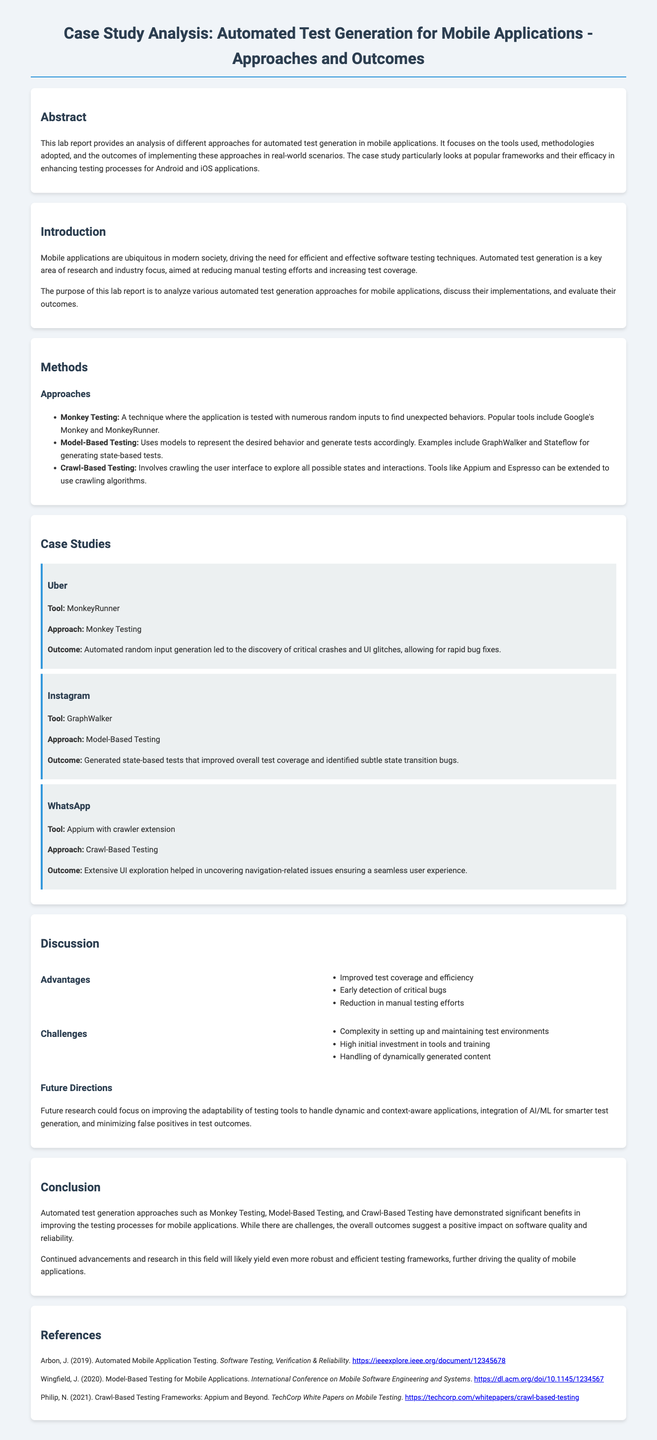What is the purpose of this lab report? The purpose is to analyze various automated test generation approaches for mobile applications, discuss their implementations, and evaluate their outcomes.
Answer: To analyze various automated test generation approaches What testing approach does Uber use? The document states that Uber used Monkey Testing as their approach.
Answer: Monkey Testing What tool is associated with Instagram's testing approach? Instagram's case study mentions GraphWalker as the tool used for testing.
Answer: GraphWalker What are the three testing approaches discussed? The three approaches are Monkey Testing, Model-Based Testing, and Crawl-Based Testing.
Answer: Monkey Testing, Model-Based Testing, Crawl-Based Testing What challenge is mentioned regarding automated testing? The document lists complexity in setting up and maintaining test environments as a challenge.
Answer: Complexity in setting up and maintaining test environments What improvement does Model-Based Testing provide? The report states that Model-Based Testing improved overall test coverage.
Answer: Improved overall test coverage In which section are future directions discussed? Future directions are discussed in the Discussion section of the document.
Answer: Discussion How many case studies are presented in the report? The report presents three case studies: Uber, Instagram, and WhatsApp.
Answer: Three 